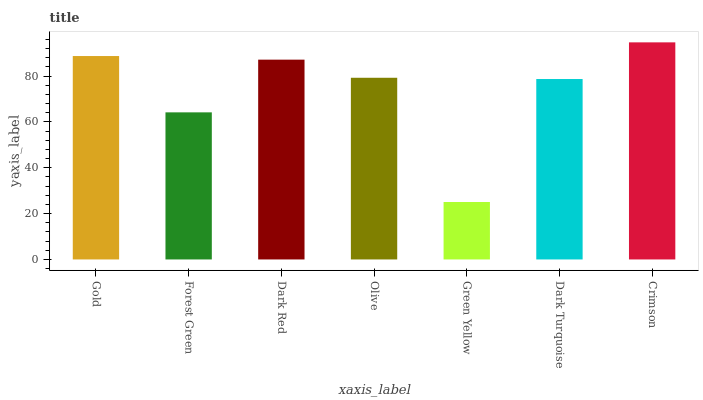Is Green Yellow the minimum?
Answer yes or no. Yes. Is Crimson the maximum?
Answer yes or no. Yes. Is Forest Green the minimum?
Answer yes or no. No. Is Forest Green the maximum?
Answer yes or no. No. Is Gold greater than Forest Green?
Answer yes or no. Yes. Is Forest Green less than Gold?
Answer yes or no. Yes. Is Forest Green greater than Gold?
Answer yes or no. No. Is Gold less than Forest Green?
Answer yes or no. No. Is Olive the high median?
Answer yes or no. Yes. Is Olive the low median?
Answer yes or no. Yes. Is Gold the high median?
Answer yes or no. No. Is Dark Turquoise the low median?
Answer yes or no. No. 